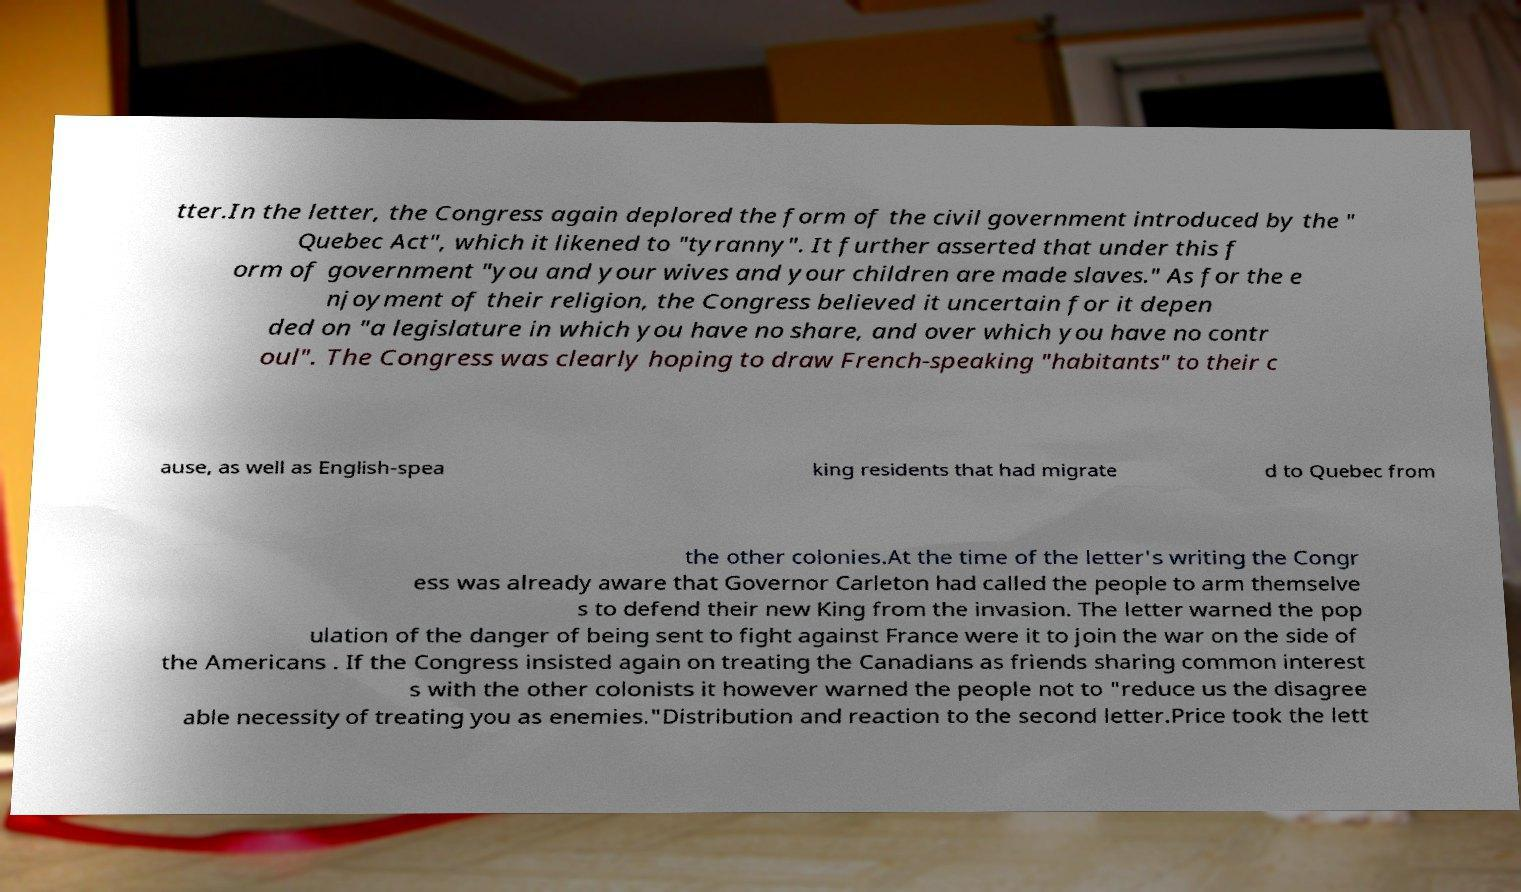Could you assist in decoding the text presented in this image and type it out clearly? tter.In the letter, the Congress again deplored the form of the civil government introduced by the " Quebec Act", which it likened to "tyranny". It further asserted that under this f orm of government "you and your wives and your children are made slaves." As for the e njoyment of their religion, the Congress believed it uncertain for it depen ded on "a legislature in which you have no share, and over which you have no contr oul". The Congress was clearly hoping to draw French-speaking "habitants" to their c ause, as well as English-spea king residents that had migrate d to Quebec from the other colonies.At the time of the letter's writing the Congr ess was already aware that Governor Carleton had called the people to arm themselve s to defend their new King from the invasion. The letter warned the pop ulation of the danger of being sent to fight against France were it to join the war on the side of the Americans . If the Congress insisted again on treating the Canadians as friends sharing common interest s with the other colonists it however warned the people not to "reduce us the disagree able necessity of treating you as enemies."Distribution and reaction to the second letter.Price took the lett 